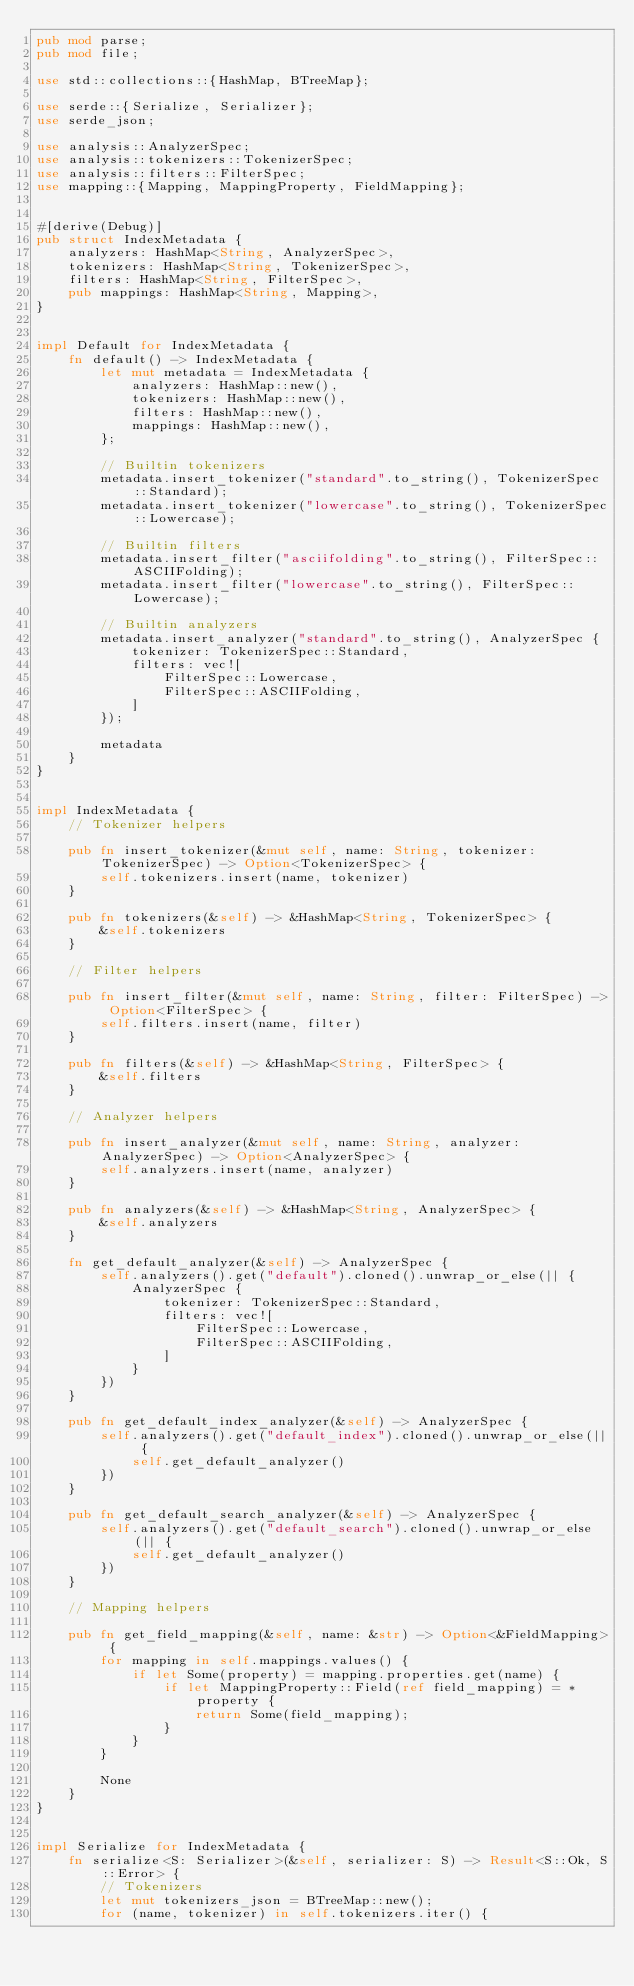<code> <loc_0><loc_0><loc_500><loc_500><_Rust_>pub mod parse;
pub mod file;

use std::collections::{HashMap, BTreeMap};

use serde::{Serialize, Serializer};
use serde_json;

use analysis::AnalyzerSpec;
use analysis::tokenizers::TokenizerSpec;
use analysis::filters::FilterSpec;
use mapping::{Mapping, MappingProperty, FieldMapping};


#[derive(Debug)]
pub struct IndexMetadata {
    analyzers: HashMap<String, AnalyzerSpec>,
    tokenizers: HashMap<String, TokenizerSpec>,
    filters: HashMap<String, FilterSpec>,
    pub mappings: HashMap<String, Mapping>,
}


impl Default for IndexMetadata {
    fn default() -> IndexMetadata {
        let mut metadata = IndexMetadata {
            analyzers: HashMap::new(),
            tokenizers: HashMap::new(),
            filters: HashMap::new(),
            mappings: HashMap::new(),
        };

        // Builtin tokenizers
        metadata.insert_tokenizer("standard".to_string(), TokenizerSpec::Standard);
        metadata.insert_tokenizer("lowercase".to_string(), TokenizerSpec::Lowercase);

        // Builtin filters
        metadata.insert_filter("asciifolding".to_string(), FilterSpec::ASCIIFolding);
        metadata.insert_filter("lowercase".to_string(), FilterSpec::Lowercase);

        // Builtin analyzers
        metadata.insert_analyzer("standard".to_string(), AnalyzerSpec {
            tokenizer: TokenizerSpec::Standard,
            filters: vec![
                FilterSpec::Lowercase,
                FilterSpec::ASCIIFolding,
            ]
        });

        metadata
    }
}


impl IndexMetadata {
    // Tokenizer helpers

    pub fn insert_tokenizer(&mut self, name: String, tokenizer: TokenizerSpec) -> Option<TokenizerSpec> {
        self.tokenizers.insert(name, tokenizer)
    }

    pub fn tokenizers(&self) -> &HashMap<String, TokenizerSpec> {
        &self.tokenizers
    }

    // Filter helpers

    pub fn insert_filter(&mut self, name: String, filter: FilterSpec) -> Option<FilterSpec> {
        self.filters.insert(name, filter)
    }

    pub fn filters(&self) -> &HashMap<String, FilterSpec> {
        &self.filters
    }

    // Analyzer helpers

    pub fn insert_analyzer(&mut self, name: String, analyzer: AnalyzerSpec) -> Option<AnalyzerSpec> {
        self.analyzers.insert(name, analyzer)
    }

    pub fn analyzers(&self) -> &HashMap<String, AnalyzerSpec> {
        &self.analyzers
    }

    fn get_default_analyzer(&self) -> AnalyzerSpec {
        self.analyzers().get("default").cloned().unwrap_or_else(|| {
            AnalyzerSpec {
                tokenizer: TokenizerSpec::Standard,
                filters: vec![
                    FilterSpec::Lowercase,
                    FilterSpec::ASCIIFolding,
                ]
            }
        })
    }

    pub fn get_default_index_analyzer(&self) -> AnalyzerSpec {
        self.analyzers().get("default_index").cloned().unwrap_or_else(|| {
            self.get_default_analyzer()
        })
    }

    pub fn get_default_search_analyzer(&self) -> AnalyzerSpec {
        self.analyzers().get("default_search").cloned().unwrap_or_else(|| {
            self.get_default_analyzer()
        })
    }

    // Mapping helpers

    pub fn get_field_mapping(&self, name: &str) -> Option<&FieldMapping> {
        for mapping in self.mappings.values() {
            if let Some(property) = mapping.properties.get(name) {
                if let MappingProperty::Field(ref field_mapping) = *property {
                    return Some(field_mapping);
                }
            }
        }

        None
    }
}


impl Serialize for IndexMetadata {
    fn serialize<S: Serializer>(&self, serializer: S) -> Result<S::Ok, S::Error> {
        // Tokenizers
        let mut tokenizers_json = BTreeMap::new();
        for (name, tokenizer) in self.tokenizers.iter() {</code> 